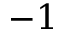Convert formula to latex. <formula><loc_0><loc_0><loc_500><loc_500>- 1</formula> 